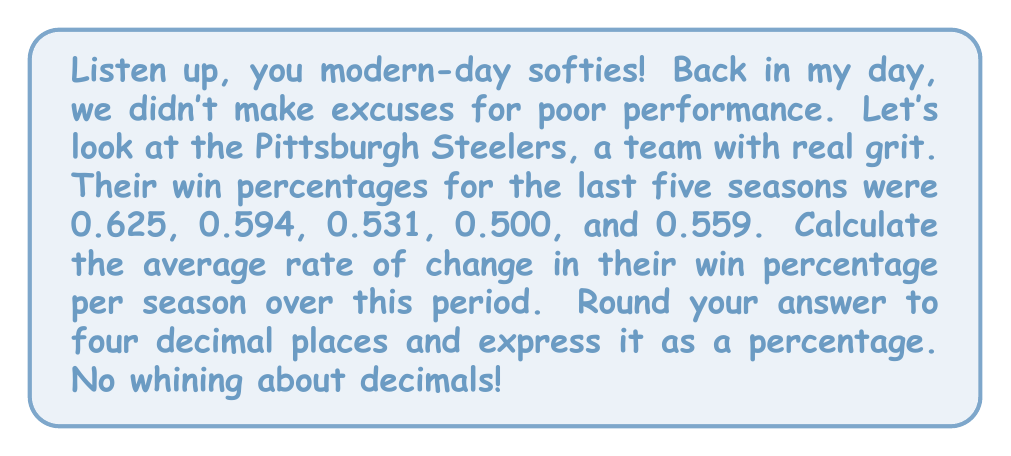Can you solve this math problem? Alright, let's break this down step-by-step, no fancy tricks:

1) First, we need to identify our initial and final values:
   Initial win percentage (5 seasons ago): 0.625
   Final win percentage (most recent season): 0.559

2) Now, we calculate the total change in win percentage:
   $\Delta y = 0.559 - 0.625 = -0.066$

3) We're looking at a span of 5 seasons, so our change in x (time) is 4:
   $\Delta x = 4$

4) The rate of change is given by the formula:
   $\text{Rate of change} = \frac{\Delta y}{\Delta x}$

5) Plugging in our values:
   $\text{Rate of change} = \frac{-0.066}{4} = -0.0165$

6) Converting to a percentage:
   $-0.0165 \times 100 = -1.65\%$

7) Rounding to four decimal places:
   $-1.6500\%$

That's a decrease of 1.65% per season on average. No excuses, just the cold, hard facts!
Answer: $-1.6500\%$ 